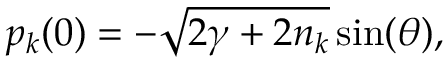<formula> <loc_0><loc_0><loc_500><loc_500>p _ { k } ( 0 ) = - \sqrt { 2 \gamma + 2 n _ { k } } \sin ( \theta ) ,</formula> 